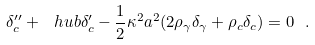<formula> <loc_0><loc_0><loc_500><loc_500>\delta _ { c } ^ { \prime \prime } + \ h u b \delta _ { c } ^ { \prime } - \frac { 1 } { 2 } \kappa ^ { 2 } a ^ { 2 } ( 2 \rho _ { \gamma } \delta _ { \gamma } + \rho _ { c } \delta _ { c } ) = 0 \ .</formula> 